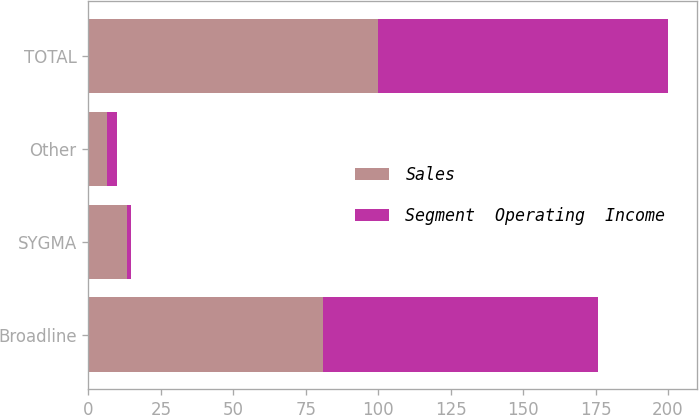Convert chart. <chart><loc_0><loc_0><loc_500><loc_500><stacked_bar_chart><ecel><fcel>Broadline<fcel>SYGMA<fcel>Other<fcel>TOTAL<nl><fcel>Sales<fcel>81<fcel>13.3<fcel>6.3<fcel>100<nl><fcel>Segment  Operating  Income<fcel>94.9<fcel>1.5<fcel>3.6<fcel>100<nl></chart> 